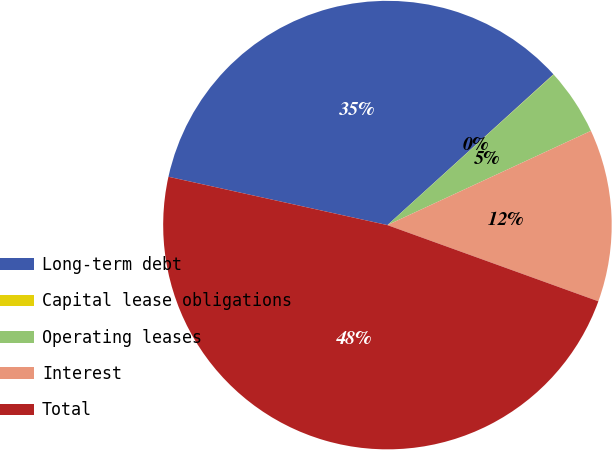<chart> <loc_0><loc_0><loc_500><loc_500><pie_chart><fcel>Long-term debt<fcel>Capital lease obligations<fcel>Operating leases<fcel>Interest<fcel>Total<nl><fcel>34.81%<fcel>0.02%<fcel>4.81%<fcel>12.42%<fcel>47.94%<nl></chart> 